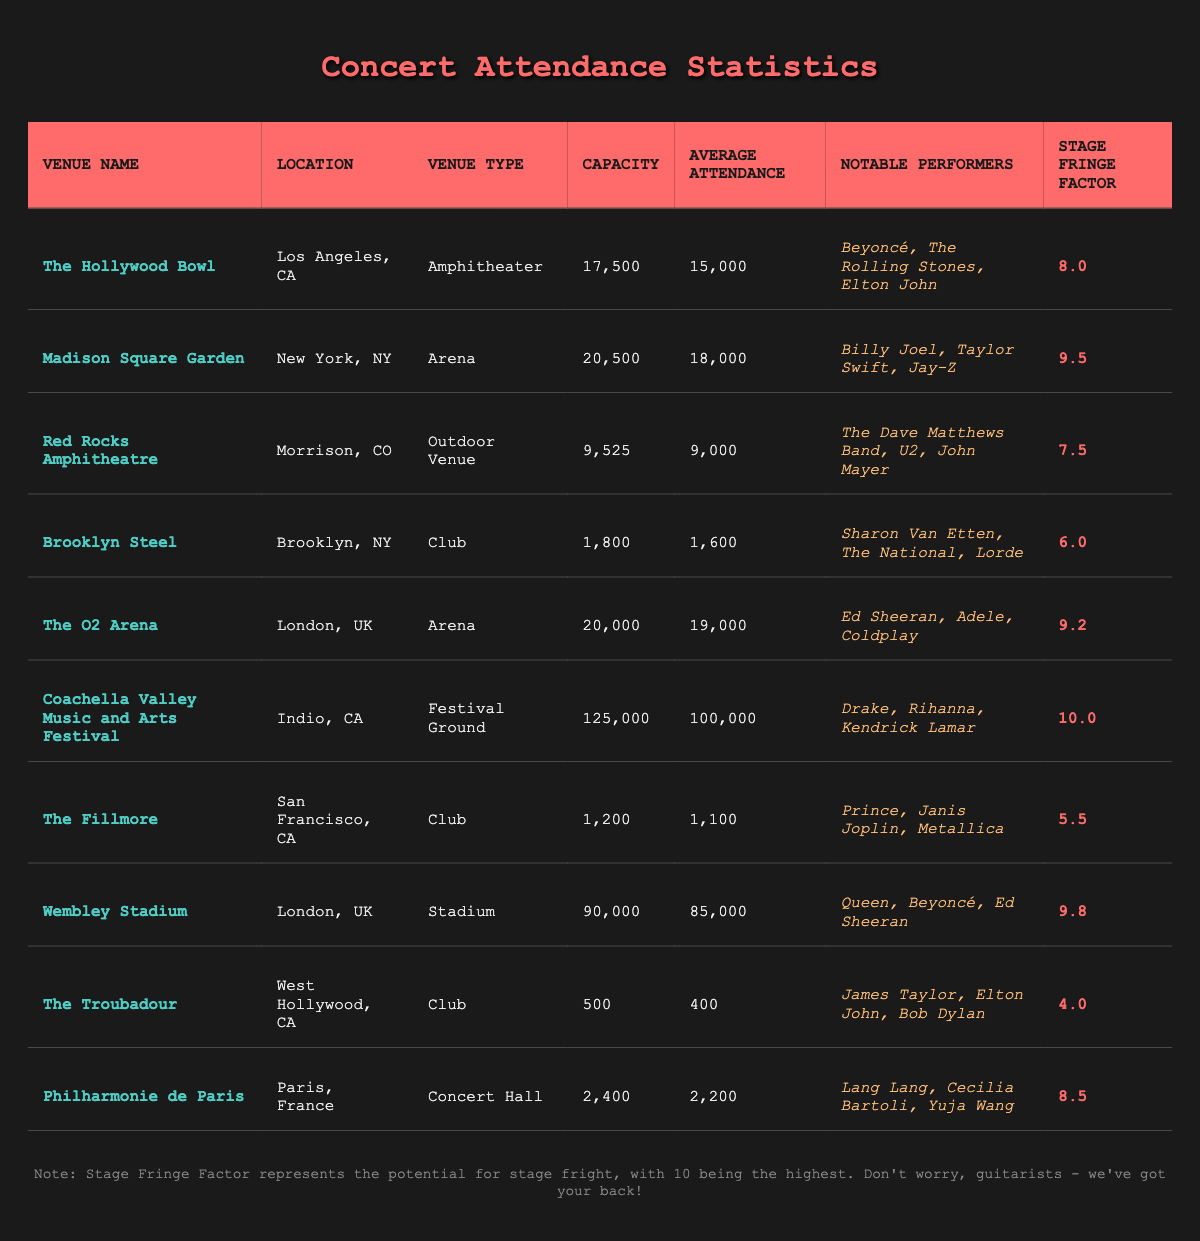What is the maximum capacity of a venue listed in the table? The venues in the table have the following capacities: The Hollywood Bowl (17,500), Madison Square Garden (20,500), Red Rocks Amphitheatre (9,525), Brooklyn Steel (1,800), The O2 Arena (20,000), Coachella Valley Music and Arts Festival (125,000), The Fillmore (1,200), Wembley Stadium (90,000), The Troubadour (500), Philharmonie de Paris (2,400). The highest capacity is 125,000 for Coachella Valley Music and Arts Festival.
Answer: 125000 Which venue has the highest average attendance? The venues have the following average attendance: The Hollywood Bowl (15,000), Madison Square Garden (18,000), Red Rocks Amphitheatre (9,000), Brooklyn Steel (1,600), The O2 Arena (19,000), Coachella Valley Music and Arts Festival (100,000), The Fillmore (1,100), Wembley Stadium (85,000), The Troubadour (400), Philharmonie de Paris (2,200). The highest average attendance is 100,000 at Coachella Valley Music and Arts Festival.
Answer: 100000 Is the average attendance of The Fillmore greater than its capacity? The Fillmore has a capacity of 1,200 and an average attendance of 1,100. Since 1,100 is less than 1,200, the average attendance is not greater than its capacity.
Answer: No How many venues have a stage fringe factor greater than 9? The venues with stage fringe factors greater than 9 are Madison Square Garden (9.5), The O2 Arena (9.2), Coachella Valley Music and Arts Festival (10.0), and Wembley Stadium (9.8). This totals four venues.
Answer: 4 What is the difference in average attendance between the venues with the highest and lowest attendance? The venue with the highest average attendance is Coachella Valley Music and Arts Festival with 100,000, and the venue with the lowest average attendance is The Troubadour with 400. To find the difference, subtract: 100,000 - 400 = 99,600.
Answer: 99600 What percentage of capacity on average do the Club venues achieve? The Club venues are Brooklyn Steel (1,800), The Fillmore (1,200), and The Troubadour (500). Their capacities are 1,800 + 1,200 + 500 = 3,500, and their average attendance is 1,600 + 1,100 + 400 = 3,100. The percentage is (3,100 / 3,500) * 100 ≈ 88.57%.
Answer: 88.57% Which venue has the most notable performers listed? The notables performers in Coachella Valley Music and Arts Festival are Drake, Rihanna, and Kendrick Lamar (3 performers), while the other venues have either 3 or fewer notable performers. Therefore, Coachella Valley Music and Arts Festival shares this distinction with multiple other venues like The Hollywood Bowl (3), Madison Square Garden (3), and others. No single venue outshines in this metric.
Answer: Coachella Valley Music and Arts Festival (along with others) Is there a venue with an average attendance exceeding its stage capacity? The venues with average attendance that exceed their capacity would be investigated. The venue with the most notable number, Coachella Valley Music and Arts Festival has a capacity of 125,000 and an average attendance of 100,000; therefore, no venue's average attendance exceeds its capacity.
Answer: No 